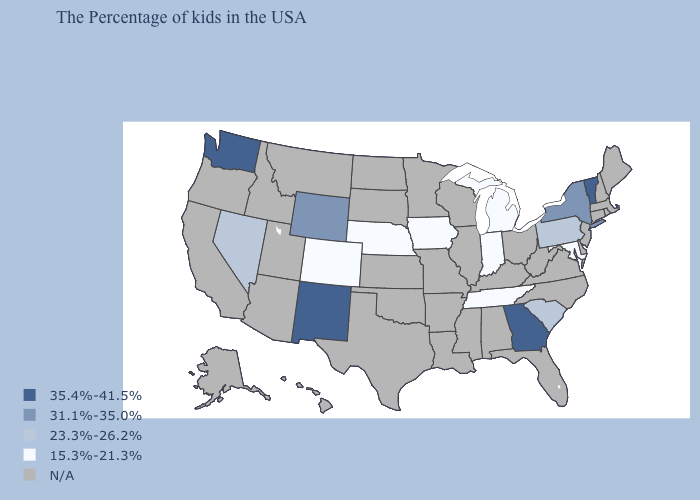Name the states that have a value in the range N/A?
Write a very short answer. Maine, Massachusetts, Rhode Island, New Hampshire, Connecticut, New Jersey, Delaware, Virginia, North Carolina, West Virginia, Ohio, Florida, Kentucky, Alabama, Wisconsin, Illinois, Mississippi, Louisiana, Missouri, Arkansas, Minnesota, Kansas, Oklahoma, Texas, South Dakota, North Dakota, Utah, Montana, Arizona, Idaho, California, Oregon, Alaska, Hawaii. What is the lowest value in the USA?
Quick response, please. 15.3%-21.3%. Which states have the highest value in the USA?
Be succinct. Vermont, Georgia, New Mexico, Washington. What is the value of New Jersey?
Write a very short answer. N/A. Name the states that have a value in the range 31.1%-35.0%?
Concise answer only. New York, Wyoming. What is the lowest value in the West?
Concise answer only. 15.3%-21.3%. Name the states that have a value in the range 15.3%-21.3%?
Answer briefly. Maryland, Michigan, Indiana, Tennessee, Iowa, Nebraska, Colorado. What is the value of Nevada?
Give a very brief answer. 23.3%-26.2%. Does Georgia have the highest value in the USA?
Keep it brief. Yes. Among the states that border Wisconsin , which have the highest value?
Give a very brief answer. Michigan, Iowa. What is the value of Mississippi?
Short answer required. N/A. What is the value of Louisiana?
Quick response, please. N/A. 